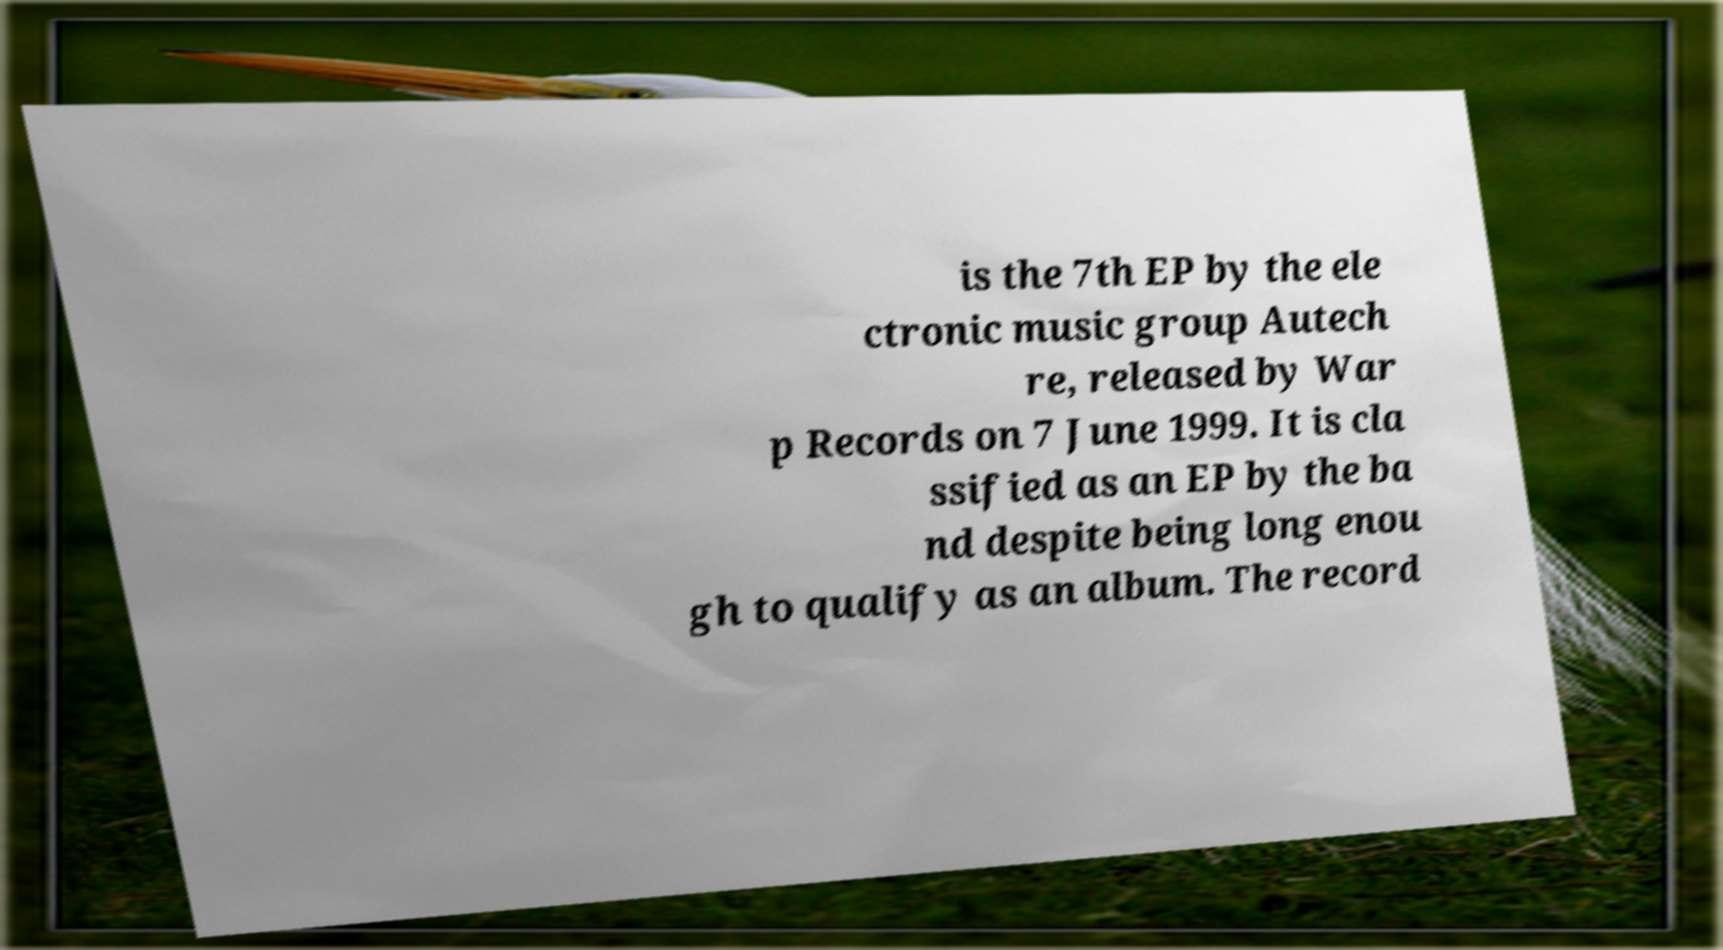Could you assist in decoding the text presented in this image and type it out clearly? is the 7th EP by the ele ctronic music group Autech re, released by War p Records on 7 June 1999. It is cla ssified as an EP by the ba nd despite being long enou gh to qualify as an album. The record 